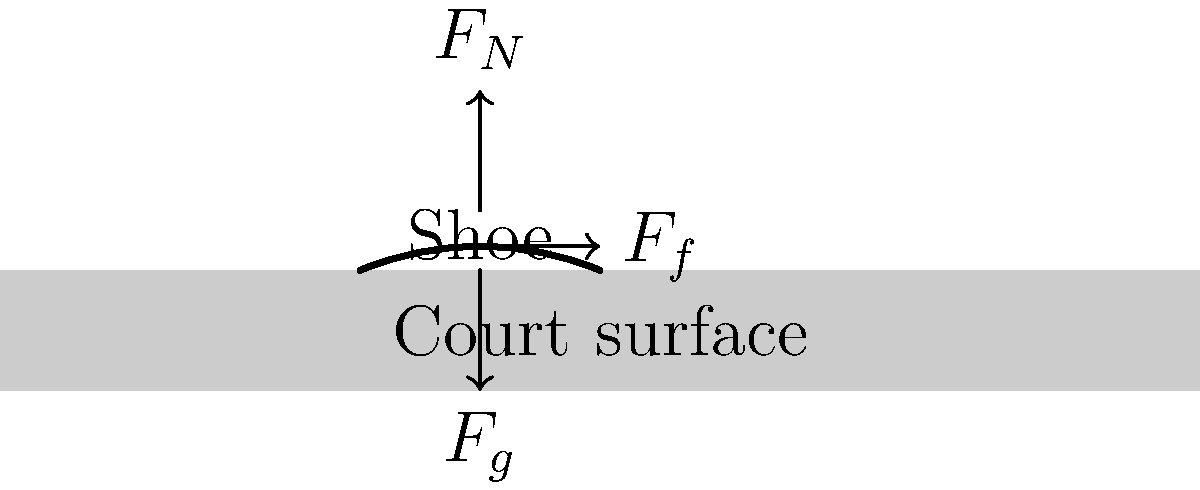As a sports memorabilia enthusiast, you've noticed different players prefer various types of basketball shoes. Consider a player wearing Jock Landale's signature shoes on a standard indoor basketball court. If the coefficient of static friction between the shoes and the court is 0.8, what is the maximum horizontal force the player can exert without slipping, given that their weight is 800 N? To solve this problem, we'll follow these steps:

1. Identify the relevant forces:
   - Normal force ($F_N$): upward force from the court
   - Friction force ($F_f$): horizontal force preventing slipping
   - Gravity ($F_g$): downward force due to the player's weight

2. Recall the equation for maximum static friction:
   $F_f \leq \mu_s F_N$
   where $\mu_s$ is the coefficient of static friction

3. In this case, the normal force equals the player's weight:
   $F_N = 800 \text{ N}$

4. Use the given coefficient of static friction:
   $\mu_s = 0.8$

5. Calculate the maximum friction force:
   $F_f = \mu_s F_N = 0.8 \times 800 \text{ N} = 640 \text{ N}$

6. The maximum horizontal force the player can exert without slipping is equal to the maximum friction force.

Therefore, the player can exert a maximum horizontal force of 640 N without slipping.
Answer: 640 N 